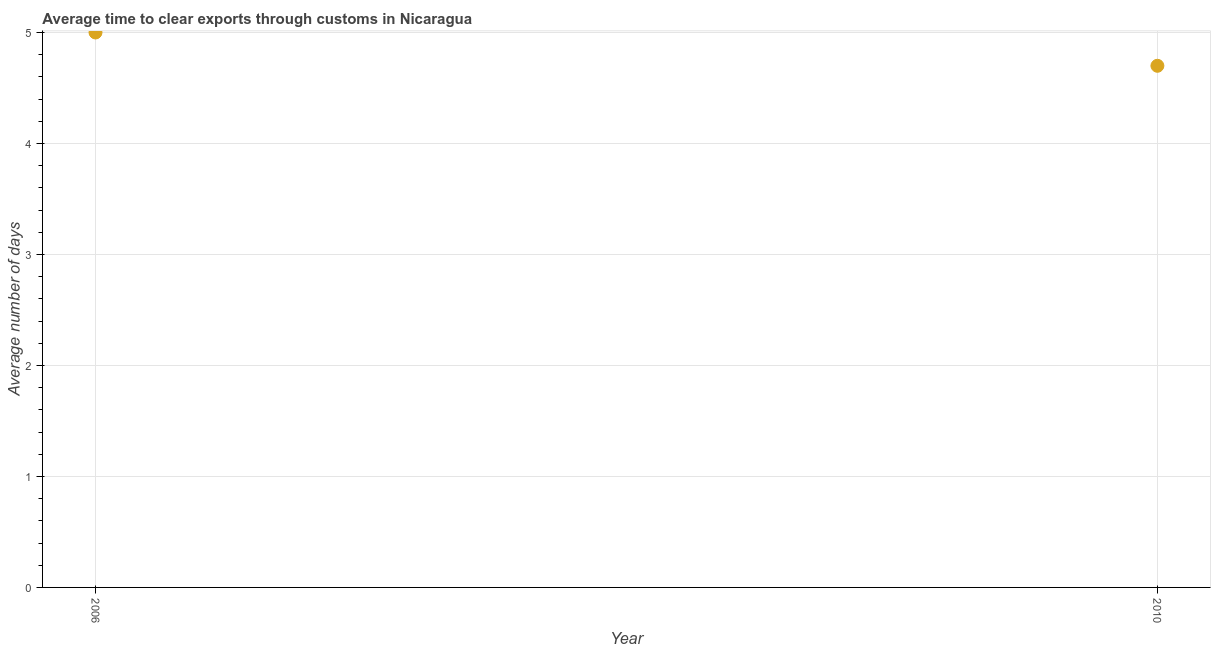What is the time to clear exports through customs in 2010?
Provide a succinct answer. 4.7. Across all years, what is the maximum time to clear exports through customs?
Your answer should be very brief. 5. Across all years, what is the minimum time to clear exports through customs?
Your answer should be compact. 4.7. In which year was the time to clear exports through customs minimum?
Offer a very short reply. 2010. What is the difference between the time to clear exports through customs in 2006 and 2010?
Your answer should be compact. 0.3. What is the average time to clear exports through customs per year?
Keep it short and to the point. 4.85. What is the median time to clear exports through customs?
Offer a very short reply. 4.85. In how many years, is the time to clear exports through customs greater than 3.6 days?
Your response must be concise. 2. What is the ratio of the time to clear exports through customs in 2006 to that in 2010?
Offer a very short reply. 1.06. Does the time to clear exports through customs monotonically increase over the years?
Your response must be concise. No. How many dotlines are there?
Ensure brevity in your answer.  1. How many years are there in the graph?
Your answer should be compact. 2. What is the difference between two consecutive major ticks on the Y-axis?
Offer a very short reply. 1. Does the graph contain any zero values?
Keep it short and to the point. No. What is the title of the graph?
Your answer should be compact. Average time to clear exports through customs in Nicaragua. What is the label or title of the Y-axis?
Your response must be concise. Average number of days. What is the difference between the Average number of days in 2006 and 2010?
Give a very brief answer. 0.3. What is the ratio of the Average number of days in 2006 to that in 2010?
Your answer should be very brief. 1.06. 